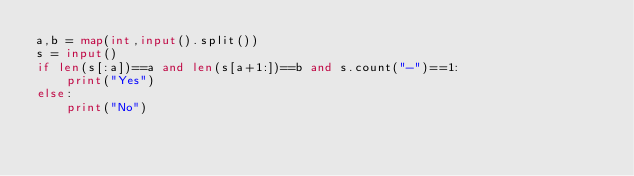<code> <loc_0><loc_0><loc_500><loc_500><_Python_>a,b = map(int,input().split())
s = input()
if len(s[:a])==a and len(s[a+1:])==b and s.count("-")==1:
    print("Yes")
else:
    print("No")</code> 